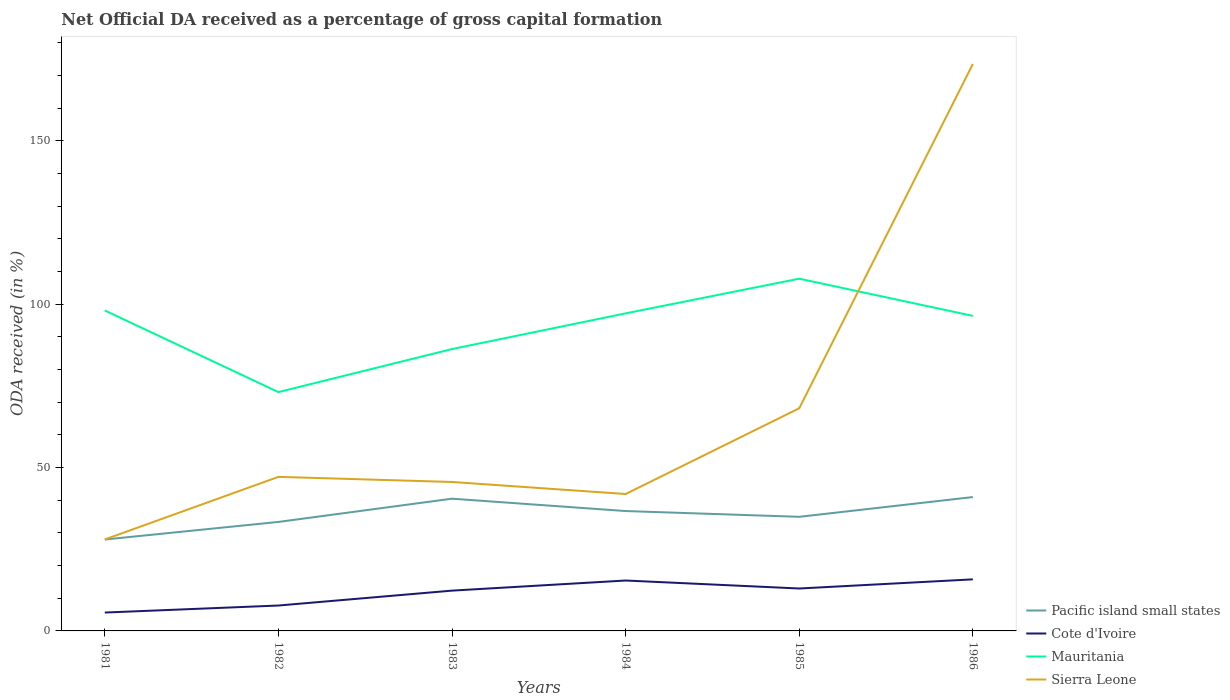Does the line corresponding to Cote d'Ivoire intersect with the line corresponding to Pacific island small states?
Give a very brief answer. No. Is the number of lines equal to the number of legend labels?
Give a very brief answer. Yes. Across all years, what is the maximum net ODA received in Cote d'Ivoire?
Ensure brevity in your answer.  5.63. In which year was the net ODA received in Mauritania maximum?
Your answer should be compact. 1982. What is the total net ODA received in Cote d'Ivoire in the graph?
Keep it short and to the point. -7.36. What is the difference between the highest and the second highest net ODA received in Mauritania?
Keep it short and to the point. 34.72. How many years are there in the graph?
Your response must be concise. 6. Does the graph contain any zero values?
Provide a succinct answer. No. Does the graph contain grids?
Offer a terse response. No. How are the legend labels stacked?
Offer a terse response. Vertical. What is the title of the graph?
Offer a very short reply. Net Official DA received as a percentage of gross capital formation. What is the label or title of the Y-axis?
Your answer should be compact. ODA received (in %). What is the ODA received (in %) of Pacific island small states in 1981?
Keep it short and to the point. 27.99. What is the ODA received (in %) in Cote d'Ivoire in 1981?
Make the answer very short. 5.63. What is the ODA received (in %) of Mauritania in 1981?
Provide a succinct answer. 98.11. What is the ODA received (in %) of Sierra Leone in 1981?
Your response must be concise. 28. What is the ODA received (in %) in Pacific island small states in 1982?
Offer a terse response. 33.37. What is the ODA received (in %) in Cote d'Ivoire in 1982?
Ensure brevity in your answer.  7.78. What is the ODA received (in %) of Mauritania in 1982?
Make the answer very short. 73.12. What is the ODA received (in %) of Sierra Leone in 1982?
Provide a short and direct response. 47.16. What is the ODA received (in %) in Pacific island small states in 1983?
Ensure brevity in your answer.  40.48. What is the ODA received (in %) of Cote d'Ivoire in 1983?
Your answer should be very brief. 12.34. What is the ODA received (in %) in Mauritania in 1983?
Your answer should be compact. 86.29. What is the ODA received (in %) in Sierra Leone in 1983?
Your answer should be very brief. 45.6. What is the ODA received (in %) of Pacific island small states in 1984?
Give a very brief answer. 36.7. What is the ODA received (in %) of Cote d'Ivoire in 1984?
Provide a short and direct response. 15.43. What is the ODA received (in %) in Mauritania in 1984?
Your response must be concise. 97.21. What is the ODA received (in %) in Sierra Leone in 1984?
Provide a succinct answer. 41.91. What is the ODA received (in %) of Pacific island small states in 1985?
Your answer should be compact. 34.93. What is the ODA received (in %) in Cote d'Ivoire in 1985?
Provide a short and direct response. 12.99. What is the ODA received (in %) of Mauritania in 1985?
Your answer should be compact. 107.84. What is the ODA received (in %) of Sierra Leone in 1985?
Make the answer very short. 68.16. What is the ODA received (in %) of Pacific island small states in 1986?
Provide a succinct answer. 40.98. What is the ODA received (in %) in Cote d'Ivoire in 1986?
Make the answer very short. 15.79. What is the ODA received (in %) in Mauritania in 1986?
Offer a very short reply. 96.44. What is the ODA received (in %) in Sierra Leone in 1986?
Provide a short and direct response. 173.56. Across all years, what is the maximum ODA received (in %) of Pacific island small states?
Offer a very short reply. 40.98. Across all years, what is the maximum ODA received (in %) in Cote d'Ivoire?
Provide a short and direct response. 15.79. Across all years, what is the maximum ODA received (in %) of Mauritania?
Offer a very short reply. 107.84. Across all years, what is the maximum ODA received (in %) in Sierra Leone?
Offer a very short reply. 173.56. Across all years, what is the minimum ODA received (in %) of Pacific island small states?
Provide a succinct answer. 27.99. Across all years, what is the minimum ODA received (in %) of Cote d'Ivoire?
Offer a very short reply. 5.63. Across all years, what is the minimum ODA received (in %) in Mauritania?
Your answer should be very brief. 73.12. Across all years, what is the minimum ODA received (in %) in Sierra Leone?
Keep it short and to the point. 28. What is the total ODA received (in %) in Pacific island small states in the graph?
Offer a terse response. 214.45. What is the total ODA received (in %) in Cote d'Ivoire in the graph?
Provide a short and direct response. 69.94. What is the total ODA received (in %) in Mauritania in the graph?
Give a very brief answer. 559.01. What is the total ODA received (in %) in Sierra Leone in the graph?
Your response must be concise. 404.4. What is the difference between the ODA received (in %) of Pacific island small states in 1981 and that in 1982?
Make the answer very short. -5.38. What is the difference between the ODA received (in %) of Cote d'Ivoire in 1981 and that in 1982?
Make the answer very short. -2.15. What is the difference between the ODA received (in %) in Mauritania in 1981 and that in 1982?
Provide a short and direct response. 24.98. What is the difference between the ODA received (in %) in Sierra Leone in 1981 and that in 1982?
Your answer should be very brief. -19.16. What is the difference between the ODA received (in %) in Pacific island small states in 1981 and that in 1983?
Provide a succinct answer. -12.5. What is the difference between the ODA received (in %) in Cote d'Ivoire in 1981 and that in 1983?
Offer a terse response. -6.71. What is the difference between the ODA received (in %) in Mauritania in 1981 and that in 1983?
Provide a succinct answer. 11.82. What is the difference between the ODA received (in %) in Sierra Leone in 1981 and that in 1983?
Provide a short and direct response. -17.6. What is the difference between the ODA received (in %) of Pacific island small states in 1981 and that in 1984?
Ensure brevity in your answer.  -8.71. What is the difference between the ODA received (in %) of Cote d'Ivoire in 1981 and that in 1984?
Ensure brevity in your answer.  -9.8. What is the difference between the ODA received (in %) of Mauritania in 1981 and that in 1984?
Keep it short and to the point. 0.89. What is the difference between the ODA received (in %) of Sierra Leone in 1981 and that in 1984?
Your answer should be compact. -13.91. What is the difference between the ODA received (in %) of Pacific island small states in 1981 and that in 1985?
Provide a succinct answer. -6.95. What is the difference between the ODA received (in %) of Cote d'Ivoire in 1981 and that in 1985?
Give a very brief answer. -7.36. What is the difference between the ODA received (in %) of Mauritania in 1981 and that in 1985?
Your answer should be compact. -9.73. What is the difference between the ODA received (in %) of Sierra Leone in 1981 and that in 1985?
Offer a terse response. -40.16. What is the difference between the ODA received (in %) of Pacific island small states in 1981 and that in 1986?
Your response must be concise. -12.99. What is the difference between the ODA received (in %) of Cote d'Ivoire in 1981 and that in 1986?
Provide a succinct answer. -10.16. What is the difference between the ODA received (in %) of Mauritania in 1981 and that in 1986?
Your answer should be very brief. 1.66. What is the difference between the ODA received (in %) in Sierra Leone in 1981 and that in 1986?
Give a very brief answer. -145.56. What is the difference between the ODA received (in %) in Pacific island small states in 1982 and that in 1983?
Your answer should be very brief. -7.11. What is the difference between the ODA received (in %) in Cote d'Ivoire in 1982 and that in 1983?
Offer a very short reply. -4.56. What is the difference between the ODA received (in %) of Mauritania in 1982 and that in 1983?
Your response must be concise. -13.17. What is the difference between the ODA received (in %) of Sierra Leone in 1982 and that in 1983?
Provide a short and direct response. 1.56. What is the difference between the ODA received (in %) of Pacific island small states in 1982 and that in 1984?
Give a very brief answer. -3.33. What is the difference between the ODA received (in %) in Cote d'Ivoire in 1982 and that in 1984?
Make the answer very short. -7.65. What is the difference between the ODA received (in %) in Mauritania in 1982 and that in 1984?
Provide a succinct answer. -24.09. What is the difference between the ODA received (in %) of Sierra Leone in 1982 and that in 1984?
Provide a short and direct response. 5.25. What is the difference between the ODA received (in %) in Pacific island small states in 1982 and that in 1985?
Provide a succinct answer. -1.57. What is the difference between the ODA received (in %) of Cote d'Ivoire in 1982 and that in 1985?
Your answer should be compact. -5.21. What is the difference between the ODA received (in %) in Mauritania in 1982 and that in 1985?
Your response must be concise. -34.72. What is the difference between the ODA received (in %) in Sierra Leone in 1982 and that in 1985?
Offer a terse response. -21. What is the difference between the ODA received (in %) of Pacific island small states in 1982 and that in 1986?
Offer a terse response. -7.61. What is the difference between the ODA received (in %) in Cote d'Ivoire in 1982 and that in 1986?
Make the answer very short. -8.01. What is the difference between the ODA received (in %) in Mauritania in 1982 and that in 1986?
Offer a terse response. -23.32. What is the difference between the ODA received (in %) of Sierra Leone in 1982 and that in 1986?
Your response must be concise. -126.4. What is the difference between the ODA received (in %) in Pacific island small states in 1983 and that in 1984?
Ensure brevity in your answer.  3.78. What is the difference between the ODA received (in %) of Cote d'Ivoire in 1983 and that in 1984?
Your answer should be very brief. -3.09. What is the difference between the ODA received (in %) of Mauritania in 1983 and that in 1984?
Give a very brief answer. -10.92. What is the difference between the ODA received (in %) in Sierra Leone in 1983 and that in 1984?
Your response must be concise. 3.69. What is the difference between the ODA received (in %) of Pacific island small states in 1983 and that in 1985?
Your answer should be compact. 5.55. What is the difference between the ODA received (in %) of Cote d'Ivoire in 1983 and that in 1985?
Make the answer very short. -0.65. What is the difference between the ODA received (in %) of Mauritania in 1983 and that in 1985?
Make the answer very short. -21.55. What is the difference between the ODA received (in %) in Sierra Leone in 1983 and that in 1985?
Your answer should be compact. -22.56. What is the difference between the ODA received (in %) in Pacific island small states in 1983 and that in 1986?
Provide a succinct answer. -0.49. What is the difference between the ODA received (in %) of Cote d'Ivoire in 1983 and that in 1986?
Your response must be concise. -3.45. What is the difference between the ODA received (in %) of Mauritania in 1983 and that in 1986?
Keep it short and to the point. -10.15. What is the difference between the ODA received (in %) in Sierra Leone in 1983 and that in 1986?
Give a very brief answer. -127.96. What is the difference between the ODA received (in %) in Pacific island small states in 1984 and that in 1985?
Your answer should be very brief. 1.76. What is the difference between the ODA received (in %) of Cote d'Ivoire in 1984 and that in 1985?
Provide a succinct answer. 2.44. What is the difference between the ODA received (in %) in Mauritania in 1984 and that in 1985?
Keep it short and to the point. -10.62. What is the difference between the ODA received (in %) of Sierra Leone in 1984 and that in 1985?
Provide a short and direct response. -26.25. What is the difference between the ODA received (in %) of Pacific island small states in 1984 and that in 1986?
Keep it short and to the point. -4.28. What is the difference between the ODA received (in %) in Cote d'Ivoire in 1984 and that in 1986?
Keep it short and to the point. -0.36. What is the difference between the ODA received (in %) in Mauritania in 1984 and that in 1986?
Your answer should be very brief. 0.77. What is the difference between the ODA received (in %) of Sierra Leone in 1984 and that in 1986?
Your answer should be compact. -131.65. What is the difference between the ODA received (in %) in Pacific island small states in 1985 and that in 1986?
Your answer should be compact. -6.04. What is the difference between the ODA received (in %) in Cote d'Ivoire in 1985 and that in 1986?
Make the answer very short. -2.8. What is the difference between the ODA received (in %) in Mauritania in 1985 and that in 1986?
Ensure brevity in your answer.  11.4. What is the difference between the ODA received (in %) of Sierra Leone in 1985 and that in 1986?
Give a very brief answer. -105.4. What is the difference between the ODA received (in %) in Pacific island small states in 1981 and the ODA received (in %) in Cote d'Ivoire in 1982?
Keep it short and to the point. 20.21. What is the difference between the ODA received (in %) in Pacific island small states in 1981 and the ODA received (in %) in Mauritania in 1982?
Give a very brief answer. -45.13. What is the difference between the ODA received (in %) of Pacific island small states in 1981 and the ODA received (in %) of Sierra Leone in 1982?
Offer a very short reply. -19.18. What is the difference between the ODA received (in %) of Cote d'Ivoire in 1981 and the ODA received (in %) of Mauritania in 1982?
Your response must be concise. -67.5. What is the difference between the ODA received (in %) in Cote d'Ivoire in 1981 and the ODA received (in %) in Sierra Leone in 1982?
Offer a very short reply. -41.54. What is the difference between the ODA received (in %) in Mauritania in 1981 and the ODA received (in %) in Sierra Leone in 1982?
Your response must be concise. 50.94. What is the difference between the ODA received (in %) in Pacific island small states in 1981 and the ODA received (in %) in Cote d'Ivoire in 1983?
Make the answer very short. 15.65. What is the difference between the ODA received (in %) of Pacific island small states in 1981 and the ODA received (in %) of Mauritania in 1983?
Provide a short and direct response. -58.3. What is the difference between the ODA received (in %) of Pacific island small states in 1981 and the ODA received (in %) of Sierra Leone in 1983?
Offer a terse response. -17.62. What is the difference between the ODA received (in %) of Cote d'Ivoire in 1981 and the ODA received (in %) of Mauritania in 1983?
Provide a short and direct response. -80.67. What is the difference between the ODA received (in %) in Cote d'Ivoire in 1981 and the ODA received (in %) in Sierra Leone in 1983?
Your answer should be very brief. -39.98. What is the difference between the ODA received (in %) in Mauritania in 1981 and the ODA received (in %) in Sierra Leone in 1983?
Offer a terse response. 52.5. What is the difference between the ODA received (in %) in Pacific island small states in 1981 and the ODA received (in %) in Cote d'Ivoire in 1984?
Offer a terse response. 12.56. What is the difference between the ODA received (in %) of Pacific island small states in 1981 and the ODA received (in %) of Mauritania in 1984?
Keep it short and to the point. -69.23. What is the difference between the ODA received (in %) in Pacific island small states in 1981 and the ODA received (in %) in Sierra Leone in 1984?
Your answer should be very brief. -13.93. What is the difference between the ODA received (in %) of Cote d'Ivoire in 1981 and the ODA received (in %) of Mauritania in 1984?
Ensure brevity in your answer.  -91.59. What is the difference between the ODA received (in %) of Cote d'Ivoire in 1981 and the ODA received (in %) of Sierra Leone in 1984?
Offer a terse response. -36.29. What is the difference between the ODA received (in %) in Mauritania in 1981 and the ODA received (in %) in Sierra Leone in 1984?
Make the answer very short. 56.19. What is the difference between the ODA received (in %) of Pacific island small states in 1981 and the ODA received (in %) of Cote d'Ivoire in 1985?
Make the answer very short. 15. What is the difference between the ODA received (in %) in Pacific island small states in 1981 and the ODA received (in %) in Mauritania in 1985?
Provide a short and direct response. -79.85. What is the difference between the ODA received (in %) in Pacific island small states in 1981 and the ODA received (in %) in Sierra Leone in 1985?
Offer a terse response. -40.18. What is the difference between the ODA received (in %) of Cote d'Ivoire in 1981 and the ODA received (in %) of Mauritania in 1985?
Give a very brief answer. -102.21. What is the difference between the ODA received (in %) in Cote d'Ivoire in 1981 and the ODA received (in %) in Sierra Leone in 1985?
Keep it short and to the point. -62.54. What is the difference between the ODA received (in %) of Mauritania in 1981 and the ODA received (in %) of Sierra Leone in 1985?
Keep it short and to the point. 29.94. What is the difference between the ODA received (in %) of Pacific island small states in 1981 and the ODA received (in %) of Cote d'Ivoire in 1986?
Provide a short and direct response. 12.2. What is the difference between the ODA received (in %) of Pacific island small states in 1981 and the ODA received (in %) of Mauritania in 1986?
Make the answer very short. -68.45. What is the difference between the ODA received (in %) of Pacific island small states in 1981 and the ODA received (in %) of Sierra Leone in 1986?
Your answer should be very brief. -145.57. What is the difference between the ODA received (in %) in Cote d'Ivoire in 1981 and the ODA received (in %) in Mauritania in 1986?
Ensure brevity in your answer.  -90.82. What is the difference between the ODA received (in %) of Cote d'Ivoire in 1981 and the ODA received (in %) of Sierra Leone in 1986?
Offer a terse response. -167.93. What is the difference between the ODA received (in %) in Mauritania in 1981 and the ODA received (in %) in Sierra Leone in 1986?
Keep it short and to the point. -75.45. What is the difference between the ODA received (in %) of Pacific island small states in 1982 and the ODA received (in %) of Cote d'Ivoire in 1983?
Provide a short and direct response. 21.03. What is the difference between the ODA received (in %) of Pacific island small states in 1982 and the ODA received (in %) of Mauritania in 1983?
Your answer should be compact. -52.92. What is the difference between the ODA received (in %) in Pacific island small states in 1982 and the ODA received (in %) in Sierra Leone in 1983?
Your response must be concise. -12.23. What is the difference between the ODA received (in %) of Cote d'Ivoire in 1982 and the ODA received (in %) of Mauritania in 1983?
Your answer should be very brief. -78.52. What is the difference between the ODA received (in %) of Cote d'Ivoire in 1982 and the ODA received (in %) of Sierra Leone in 1983?
Keep it short and to the point. -37.83. What is the difference between the ODA received (in %) of Mauritania in 1982 and the ODA received (in %) of Sierra Leone in 1983?
Provide a succinct answer. 27.52. What is the difference between the ODA received (in %) of Pacific island small states in 1982 and the ODA received (in %) of Cote d'Ivoire in 1984?
Offer a terse response. 17.94. What is the difference between the ODA received (in %) of Pacific island small states in 1982 and the ODA received (in %) of Mauritania in 1984?
Offer a very short reply. -63.85. What is the difference between the ODA received (in %) of Pacific island small states in 1982 and the ODA received (in %) of Sierra Leone in 1984?
Offer a very short reply. -8.54. What is the difference between the ODA received (in %) of Cote d'Ivoire in 1982 and the ODA received (in %) of Mauritania in 1984?
Offer a terse response. -89.44. What is the difference between the ODA received (in %) in Cote d'Ivoire in 1982 and the ODA received (in %) in Sierra Leone in 1984?
Keep it short and to the point. -34.14. What is the difference between the ODA received (in %) of Mauritania in 1982 and the ODA received (in %) of Sierra Leone in 1984?
Provide a short and direct response. 31.21. What is the difference between the ODA received (in %) in Pacific island small states in 1982 and the ODA received (in %) in Cote d'Ivoire in 1985?
Your response must be concise. 20.38. What is the difference between the ODA received (in %) of Pacific island small states in 1982 and the ODA received (in %) of Mauritania in 1985?
Ensure brevity in your answer.  -74.47. What is the difference between the ODA received (in %) in Pacific island small states in 1982 and the ODA received (in %) in Sierra Leone in 1985?
Offer a terse response. -34.79. What is the difference between the ODA received (in %) of Cote d'Ivoire in 1982 and the ODA received (in %) of Mauritania in 1985?
Ensure brevity in your answer.  -100.06. What is the difference between the ODA received (in %) in Cote d'Ivoire in 1982 and the ODA received (in %) in Sierra Leone in 1985?
Ensure brevity in your answer.  -60.39. What is the difference between the ODA received (in %) of Mauritania in 1982 and the ODA received (in %) of Sierra Leone in 1985?
Offer a terse response. 4.96. What is the difference between the ODA received (in %) in Pacific island small states in 1982 and the ODA received (in %) in Cote d'Ivoire in 1986?
Offer a very short reply. 17.58. What is the difference between the ODA received (in %) of Pacific island small states in 1982 and the ODA received (in %) of Mauritania in 1986?
Your response must be concise. -63.07. What is the difference between the ODA received (in %) of Pacific island small states in 1982 and the ODA received (in %) of Sierra Leone in 1986?
Your response must be concise. -140.19. What is the difference between the ODA received (in %) of Cote d'Ivoire in 1982 and the ODA received (in %) of Mauritania in 1986?
Make the answer very short. -88.67. What is the difference between the ODA received (in %) in Cote d'Ivoire in 1982 and the ODA received (in %) in Sierra Leone in 1986?
Your answer should be very brief. -165.78. What is the difference between the ODA received (in %) in Mauritania in 1982 and the ODA received (in %) in Sierra Leone in 1986?
Give a very brief answer. -100.44. What is the difference between the ODA received (in %) in Pacific island small states in 1983 and the ODA received (in %) in Cote d'Ivoire in 1984?
Your answer should be very brief. 25.05. What is the difference between the ODA received (in %) in Pacific island small states in 1983 and the ODA received (in %) in Mauritania in 1984?
Provide a succinct answer. -56.73. What is the difference between the ODA received (in %) in Pacific island small states in 1983 and the ODA received (in %) in Sierra Leone in 1984?
Your answer should be very brief. -1.43. What is the difference between the ODA received (in %) of Cote d'Ivoire in 1983 and the ODA received (in %) of Mauritania in 1984?
Give a very brief answer. -84.88. What is the difference between the ODA received (in %) of Cote d'Ivoire in 1983 and the ODA received (in %) of Sierra Leone in 1984?
Provide a short and direct response. -29.58. What is the difference between the ODA received (in %) of Mauritania in 1983 and the ODA received (in %) of Sierra Leone in 1984?
Your response must be concise. 44.38. What is the difference between the ODA received (in %) of Pacific island small states in 1983 and the ODA received (in %) of Cote d'Ivoire in 1985?
Keep it short and to the point. 27.5. What is the difference between the ODA received (in %) in Pacific island small states in 1983 and the ODA received (in %) in Mauritania in 1985?
Keep it short and to the point. -67.35. What is the difference between the ODA received (in %) in Pacific island small states in 1983 and the ODA received (in %) in Sierra Leone in 1985?
Keep it short and to the point. -27.68. What is the difference between the ODA received (in %) in Cote d'Ivoire in 1983 and the ODA received (in %) in Mauritania in 1985?
Offer a terse response. -95.5. What is the difference between the ODA received (in %) in Cote d'Ivoire in 1983 and the ODA received (in %) in Sierra Leone in 1985?
Ensure brevity in your answer.  -55.83. What is the difference between the ODA received (in %) in Mauritania in 1983 and the ODA received (in %) in Sierra Leone in 1985?
Offer a terse response. 18.13. What is the difference between the ODA received (in %) in Pacific island small states in 1983 and the ODA received (in %) in Cote d'Ivoire in 1986?
Provide a short and direct response. 24.7. What is the difference between the ODA received (in %) in Pacific island small states in 1983 and the ODA received (in %) in Mauritania in 1986?
Provide a short and direct response. -55.96. What is the difference between the ODA received (in %) of Pacific island small states in 1983 and the ODA received (in %) of Sierra Leone in 1986?
Your answer should be compact. -133.08. What is the difference between the ODA received (in %) of Cote d'Ivoire in 1983 and the ODA received (in %) of Mauritania in 1986?
Provide a short and direct response. -84.11. What is the difference between the ODA received (in %) of Cote d'Ivoire in 1983 and the ODA received (in %) of Sierra Leone in 1986?
Keep it short and to the point. -161.22. What is the difference between the ODA received (in %) of Mauritania in 1983 and the ODA received (in %) of Sierra Leone in 1986?
Your answer should be very brief. -87.27. What is the difference between the ODA received (in %) of Pacific island small states in 1984 and the ODA received (in %) of Cote d'Ivoire in 1985?
Provide a short and direct response. 23.71. What is the difference between the ODA received (in %) in Pacific island small states in 1984 and the ODA received (in %) in Mauritania in 1985?
Provide a short and direct response. -71.14. What is the difference between the ODA received (in %) in Pacific island small states in 1984 and the ODA received (in %) in Sierra Leone in 1985?
Your answer should be compact. -31.46. What is the difference between the ODA received (in %) in Cote d'Ivoire in 1984 and the ODA received (in %) in Mauritania in 1985?
Provide a succinct answer. -92.41. What is the difference between the ODA received (in %) of Cote d'Ivoire in 1984 and the ODA received (in %) of Sierra Leone in 1985?
Offer a terse response. -52.73. What is the difference between the ODA received (in %) of Mauritania in 1984 and the ODA received (in %) of Sierra Leone in 1985?
Ensure brevity in your answer.  29.05. What is the difference between the ODA received (in %) of Pacific island small states in 1984 and the ODA received (in %) of Cote d'Ivoire in 1986?
Provide a short and direct response. 20.91. What is the difference between the ODA received (in %) in Pacific island small states in 1984 and the ODA received (in %) in Mauritania in 1986?
Provide a succinct answer. -59.74. What is the difference between the ODA received (in %) of Pacific island small states in 1984 and the ODA received (in %) of Sierra Leone in 1986?
Provide a short and direct response. -136.86. What is the difference between the ODA received (in %) of Cote d'Ivoire in 1984 and the ODA received (in %) of Mauritania in 1986?
Make the answer very short. -81.01. What is the difference between the ODA received (in %) in Cote d'Ivoire in 1984 and the ODA received (in %) in Sierra Leone in 1986?
Provide a succinct answer. -158.13. What is the difference between the ODA received (in %) of Mauritania in 1984 and the ODA received (in %) of Sierra Leone in 1986?
Provide a short and direct response. -76.34. What is the difference between the ODA received (in %) in Pacific island small states in 1985 and the ODA received (in %) in Cote d'Ivoire in 1986?
Your answer should be very brief. 19.15. What is the difference between the ODA received (in %) of Pacific island small states in 1985 and the ODA received (in %) of Mauritania in 1986?
Your answer should be very brief. -61.51. What is the difference between the ODA received (in %) of Pacific island small states in 1985 and the ODA received (in %) of Sierra Leone in 1986?
Make the answer very short. -138.63. What is the difference between the ODA received (in %) in Cote d'Ivoire in 1985 and the ODA received (in %) in Mauritania in 1986?
Make the answer very short. -83.45. What is the difference between the ODA received (in %) of Cote d'Ivoire in 1985 and the ODA received (in %) of Sierra Leone in 1986?
Give a very brief answer. -160.57. What is the difference between the ODA received (in %) in Mauritania in 1985 and the ODA received (in %) in Sierra Leone in 1986?
Your answer should be compact. -65.72. What is the average ODA received (in %) of Pacific island small states per year?
Ensure brevity in your answer.  35.74. What is the average ODA received (in %) in Cote d'Ivoire per year?
Provide a short and direct response. 11.66. What is the average ODA received (in %) in Mauritania per year?
Make the answer very short. 93.17. What is the average ODA received (in %) of Sierra Leone per year?
Your answer should be very brief. 67.4. In the year 1981, what is the difference between the ODA received (in %) in Pacific island small states and ODA received (in %) in Cote d'Ivoire?
Provide a short and direct response. 22.36. In the year 1981, what is the difference between the ODA received (in %) of Pacific island small states and ODA received (in %) of Mauritania?
Your answer should be compact. -70.12. In the year 1981, what is the difference between the ODA received (in %) in Pacific island small states and ODA received (in %) in Sierra Leone?
Your answer should be very brief. -0.02. In the year 1981, what is the difference between the ODA received (in %) of Cote d'Ivoire and ODA received (in %) of Mauritania?
Ensure brevity in your answer.  -92.48. In the year 1981, what is the difference between the ODA received (in %) of Cote d'Ivoire and ODA received (in %) of Sierra Leone?
Offer a terse response. -22.38. In the year 1981, what is the difference between the ODA received (in %) in Mauritania and ODA received (in %) in Sierra Leone?
Make the answer very short. 70.1. In the year 1982, what is the difference between the ODA received (in %) of Pacific island small states and ODA received (in %) of Cote d'Ivoire?
Your answer should be very brief. 25.59. In the year 1982, what is the difference between the ODA received (in %) in Pacific island small states and ODA received (in %) in Mauritania?
Provide a succinct answer. -39.75. In the year 1982, what is the difference between the ODA received (in %) of Pacific island small states and ODA received (in %) of Sierra Leone?
Your answer should be very brief. -13.8. In the year 1982, what is the difference between the ODA received (in %) of Cote d'Ivoire and ODA received (in %) of Mauritania?
Provide a short and direct response. -65.35. In the year 1982, what is the difference between the ODA received (in %) in Cote d'Ivoire and ODA received (in %) in Sierra Leone?
Offer a terse response. -39.39. In the year 1982, what is the difference between the ODA received (in %) in Mauritania and ODA received (in %) in Sierra Leone?
Offer a very short reply. 25.96. In the year 1983, what is the difference between the ODA received (in %) of Pacific island small states and ODA received (in %) of Cote d'Ivoire?
Ensure brevity in your answer.  28.15. In the year 1983, what is the difference between the ODA received (in %) of Pacific island small states and ODA received (in %) of Mauritania?
Your answer should be very brief. -45.81. In the year 1983, what is the difference between the ODA received (in %) in Pacific island small states and ODA received (in %) in Sierra Leone?
Your response must be concise. -5.12. In the year 1983, what is the difference between the ODA received (in %) in Cote d'Ivoire and ODA received (in %) in Mauritania?
Your answer should be very brief. -73.95. In the year 1983, what is the difference between the ODA received (in %) in Cote d'Ivoire and ODA received (in %) in Sierra Leone?
Offer a very short reply. -33.27. In the year 1983, what is the difference between the ODA received (in %) in Mauritania and ODA received (in %) in Sierra Leone?
Offer a terse response. 40.69. In the year 1984, what is the difference between the ODA received (in %) in Pacific island small states and ODA received (in %) in Cote d'Ivoire?
Ensure brevity in your answer.  21.27. In the year 1984, what is the difference between the ODA received (in %) in Pacific island small states and ODA received (in %) in Mauritania?
Give a very brief answer. -60.52. In the year 1984, what is the difference between the ODA received (in %) of Pacific island small states and ODA received (in %) of Sierra Leone?
Your answer should be compact. -5.21. In the year 1984, what is the difference between the ODA received (in %) of Cote d'Ivoire and ODA received (in %) of Mauritania?
Your answer should be compact. -81.78. In the year 1984, what is the difference between the ODA received (in %) of Cote d'Ivoire and ODA received (in %) of Sierra Leone?
Your response must be concise. -26.48. In the year 1984, what is the difference between the ODA received (in %) in Mauritania and ODA received (in %) in Sierra Leone?
Keep it short and to the point. 55.3. In the year 1985, what is the difference between the ODA received (in %) of Pacific island small states and ODA received (in %) of Cote d'Ivoire?
Give a very brief answer. 21.95. In the year 1985, what is the difference between the ODA received (in %) of Pacific island small states and ODA received (in %) of Mauritania?
Your answer should be compact. -72.9. In the year 1985, what is the difference between the ODA received (in %) of Pacific island small states and ODA received (in %) of Sierra Leone?
Your answer should be compact. -33.23. In the year 1985, what is the difference between the ODA received (in %) of Cote d'Ivoire and ODA received (in %) of Mauritania?
Provide a short and direct response. -94.85. In the year 1985, what is the difference between the ODA received (in %) in Cote d'Ivoire and ODA received (in %) in Sierra Leone?
Keep it short and to the point. -55.18. In the year 1985, what is the difference between the ODA received (in %) of Mauritania and ODA received (in %) of Sierra Leone?
Provide a short and direct response. 39.67. In the year 1986, what is the difference between the ODA received (in %) in Pacific island small states and ODA received (in %) in Cote d'Ivoire?
Make the answer very short. 25.19. In the year 1986, what is the difference between the ODA received (in %) of Pacific island small states and ODA received (in %) of Mauritania?
Provide a succinct answer. -55.46. In the year 1986, what is the difference between the ODA received (in %) in Pacific island small states and ODA received (in %) in Sierra Leone?
Give a very brief answer. -132.58. In the year 1986, what is the difference between the ODA received (in %) in Cote d'Ivoire and ODA received (in %) in Mauritania?
Ensure brevity in your answer.  -80.65. In the year 1986, what is the difference between the ODA received (in %) of Cote d'Ivoire and ODA received (in %) of Sierra Leone?
Your answer should be very brief. -157.77. In the year 1986, what is the difference between the ODA received (in %) of Mauritania and ODA received (in %) of Sierra Leone?
Offer a terse response. -77.12. What is the ratio of the ODA received (in %) of Pacific island small states in 1981 to that in 1982?
Your answer should be compact. 0.84. What is the ratio of the ODA received (in %) in Cote d'Ivoire in 1981 to that in 1982?
Your answer should be very brief. 0.72. What is the ratio of the ODA received (in %) in Mauritania in 1981 to that in 1982?
Your response must be concise. 1.34. What is the ratio of the ODA received (in %) of Sierra Leone in 1981 to that in 1982?
Provide a short and direct response. 0.59. What is the ratio of the ODA received (in %) in Pacific island small states in 1981 to that in 1983?
Offer a terse response. 0.69. What is the ratio of the ODA received (in %) in Cote d'Ivoire in 1981 to that in 1983?
Offer a terse response. 0.46. What is the ratio of the ODA received (in %) in Mauritania in 1981 to that in 1983?
Keep it short and to the point. 1.14. What is the ratio of the ODA received (in %) of Sierra Leone in 1981 to that in 1983?
Give a very brief answer. 0.61. What is the ratio of the ODA received (in %) in Pacific island small states in 1981 to that in 1984?
Keep it short and to the point. 0.76. What is the ratio of the ODA received (in %) of Cote d'Ivoire in 1981 to that in 1984?
Your answer should be very brief. 0.36. What is the ratio of the ODA received (in %) in Mauritania in 1981 to that in 1984?
Your answer should be compact. 1.01. What is the ratio of the ODA received (in %) of Sierra Leone in 1981 to that in 1984?
Provide a succinct answer. 0.67. What is the ratio of the ODA received (in %) in Pacific island small states in 1981 to that in 1985?
Keep it short and to the point. 0.8. What is the ratio of the ODA received (in %) of Cote d'Ivoire in 1981 to that in 1985?
Ensure brevity in your answer.  0.43. What is the ratio of the ODA received (in %) of Mauritania in 1981 to that in 1985?
Provide a short and direct response. 0.91. What is the ratio of the ODA received (in %) of Sierra Leone in 1981 to that in 1985?
Provide a succinct answer. 0.41. What is the ratio of the ODA received (in %) in Pacific island small states in 1981 to that in 1986?
Provide a short and direct response. 0.68. What is the ratio of the ODA received (in %) in Cote d'Ivoire in 1981 to that in 1986?
Your response must be concise. 0.36. What is the ratio of the ODA received (in %) in Mauritania in 1981 to that in 1986?
Make the answer very short. 1.02. What is the ratio of the ODA received (in %) in Sierra Leone in 1981 to that in 1986?
Ensure brevity in your answer.  0.16. What is the ratio of the ODA received (in %) of Pacific island small states in 1982 to that in 1983?
Offer a terse response. 0.82. What is the ratio of the ODA received (in %) in Cote d'Ivoire in 1982 to that in 1983?
Your answer should be very brief. 0.63. What is the ratio of the ODA received (in %) in Mauritania in 1982 to that in 1983?
Provide a succinct answer. 0.85. What is the ratio of the ODA received (in %) of Sierra Leone in 1982 to that in 1983?
Your answer should be very brief. 1.03. What is the ratio of the ODA received (in %) in Pacific island small states in 1982 to that in 1984?
Keep it short and to the point. 0.91. What is the ratio of the ODA received (in %) of Cote d'Ivoire in 1982 to that in 1984?
Offer a very short reply. 0.5. What is the ratio of the ODA received (in %) in Mauritania in 1982 to that in 1984?
Offer a terse response. 0.75. What is the ratio of the ODA received (in %) of Sierra Leone in 1982 to that in 1984?
Give a very brief answer. 1.13. What is the ratio of the ODA received (in %) of Pacific island small states in 1982 to that in 1985?
Provide a succinct answer. 0.96. What is the ratio of the ODA received (in %) in Cote d'Ivoire in 1982 to that in 1985?
Provide a short and direct response. 0.6. What is the ratio of the ODA received (in %) in Mauritania in 1982 to that in 1985?
Give a very brief answer. 0.68. What is the ratio of the ODA received (in %) in Sierra Leone in 1982 to that in 1985?
Your answer should be very brief. 0.69. What is the ratio of the ODA received (in %) in Pacific island small states in 1982 to that in 1986?
Provide a short and direct response. 0.81. What is the ratio of the ODA received (in %) in Cote d'Ivoire in 1982 to that in 1986?
Ensure brevity in your answer.  0.49. What is the ratio of the ODA received (in %) of Mauritania in 1982 to that in 1986?
Provide a succinct answer. 0.76. What is the ratio of the ODA received (in %) of Sierra Leone in 1982 to that in 1986?
Give a very brief answer. 0.27. What is the ratio of the ODA received (in %) in Pacific island small states in 1983 to that in 1984?
Provide a succinct answer. 1.1. What is the ratio of the ODA received (in %) in Cote d'Ivoire in 1983 to that in 1984?
Make the answer very short. 0.8. What is the ratio of the ODA received (in %) in Mauritania in 1983 to that in 1984?
Offer a terse response. 0.89. What is the ratio of the ODA received (in %) in Sierra Leone in 1983 to that in 1984?
Keep it short and to the point. 1.09. What is the ratio of the ODA received (in %) of Pacific island small states in 1983 to that in 1985?
Provide a succinct answer. 1.16. What is the ratio of the ODA received (in %) of Cote d'Ivoire in 1983 to that in 1985?
Your answer should be compact. 0.95. What is the ratio of the ODA received (in %) of Mauritania in 1983 to that in 1985?
Provide a succinct answer. 0.8. What is the ratio of the ODA received (in %) in Sierra Leone in 1983 to that in 1985?
Offer a very short reply. 0.67. What is the ratio of the ODA received (in %) of Pacific island small states in 1983 to that in 1986?
Make the answer very short. 0.99. What is the ratio of the ODA received (in %) of Cote d'Ivoire in 1983 to that in 1986?
Your answer should be compact. 0.78. What is the ratio of the ODA received (in %) in Mauritania in 1983 to that in 1986?
Offer a very short reply. 0.89. What is the ratio of the ODA received (in %) of Sierra Leone in 1983 to that in 1986?
Provide a short and direct response. 0.26. What is the ratio of the ODA received (in %) of Pacific island small states in 1984 to that in 1985?
Offer a very short reply. 1.05. What is the ratio of the ODA received (in %) of Cote d'Ivoire in 1984 to that in 1985?
Your answer should be compact. 1.19. What is the ratio of the ODA received (in %) of Mauritania in 1984 to that in 1985?
Keep it short and to the point. 0.9. What is the ratio of the ODA received (in %) in Sierra Leone in 1984 to that in 1985?
Your answer should be very brief. 0.61. What is the ratio of the ODA received (in %) of Pacific island small states in 1984 to that in 1986?
Your answer should be very brief. 0.9. What is the ratio of the ODA received (in %) of Cote d'Ivoire in 1984 to that in 1986?
Your response must be concise. 0.98. What is the ratio of the ODA received (in %) of Mauritania in 1984 to that in 1986?
Ensure brevity in your answer.  1.01. What is the ratio of the ODA received (in %) of Sierra Leone in 1984 to that in 1986?
Ensure brevity in your answer.  0.24. What is the ratio of the ODA received (in %) in Pacific island small states in 1985 to that in 1986?
Provide a short and direct response. 0.85. What is the ratio of the ODA received (in %) of Cote d'Ivoire in 1985 to that in 1986?
Your answer should be very brief. 0.82. What is the ratio of the ODA received (in %) of Mauritania in 1985 to that in 1986?
Provide a short and direct response. 1.12. What is the ratio of the ODA received (in %) in Sierra Leone in 1985 to that in 1986?
Offer a very short reply. 0.39. What is the difference between the highest and the second highest ODA received (in %) in Pacific island small states?
Provide a succinct answer. 0.49. What is the difference between the highest and the second highest ODA received (in %) in Cote d'Ivoire?
Provide a short and direct response. 0.36. What is the difference between the highest and the second highest ODA received (in %) of Mauritania?
Offer a terse response. 9.73. What is the difference between the highest and the second highest ODA received (in %) in Sierra Leone?
Ensure brevity in your answer.  105.4. What is the difference between the highest and the lowest ODA received (in %) of Pacific island small states?
Your answer should be very brief. 12.99. What is the difference between the highest and the lowest ODA received (in %) of Cote d'Ivoire?
Keep it short and to the point. 10.16. What is the difference between the highest and the lowest ODA received (in %) of Mauritania?
Offer a very short reply. 34.72. What is the difference between the highest and the lowest ODA received (in %) of Sierra Leone?
Your response must be concise. 145.56. 